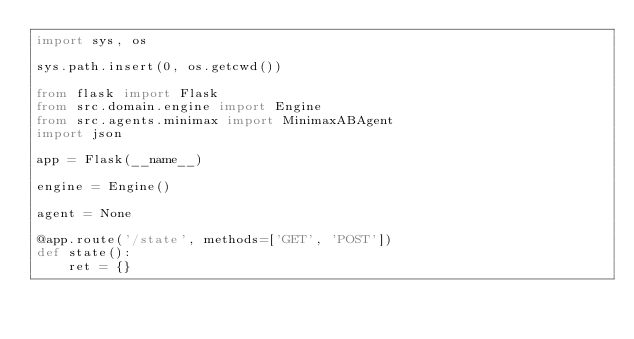Convert code to text. <code><loc_0><loc_0><loc_500><loc_500><_Python_>import sys, os

sys.path.insert(0, os.getcwd())

from flask import Flask
from src.domain.engine import Engine
from src.agents.minimax import MinimaxABAgent
import json

app = Flask(__name__)

engine = Engine()

agent = None

@app.route('/state', methods=['GET', 'POST'])
def state():
    ret = {}</code> 